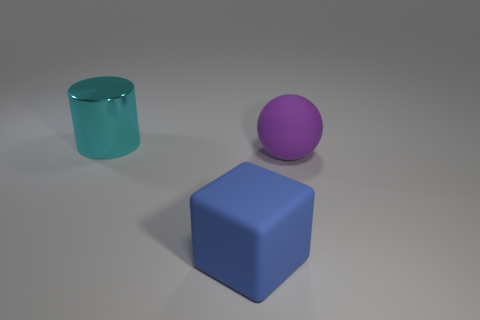Do the large cyan cylinder and the big purple thing have the same material?
Ensure brevity in your answer.  No. Are there fewer metallic cylinders that are on the right side of the matte sphere than big cyan objects behind the big cylinder?
Make the answer very short. No. How many big blue blocks are in front of the thing on the left side of the big rubber object to the left of the purple rubber sphere?
Your response must be concise. 1. The shiny thing that is the same size as the matte sphere is what color?
Ensure brevity in your answer.  Cyan. Is there a big thing on the right side of the object that is in front of the thing on the right side of the blue thing?
Give a very brief answer. Yes. There is a rubber thing that is the same size as the rubber sphere; what is its shape?
Make the answer very short. Cube. How many objects are metal cylinders or rubber spheres?
Your response must be concise. 2. Do the thing that is behind the large purple rubber thing and the big object that is in front of the purple rubber sphere have the same shape?
Your answer should be very brief. No. There is a large rubber thing that is to the right of the big blue cube; what is its shape?
Your answer should be very brief. Sphere. Are there an equal number of cyan metal things that are in front of the block and purple rubber spheres that are in front of the large cyan metal thing?
Offer a very short reply. No. 